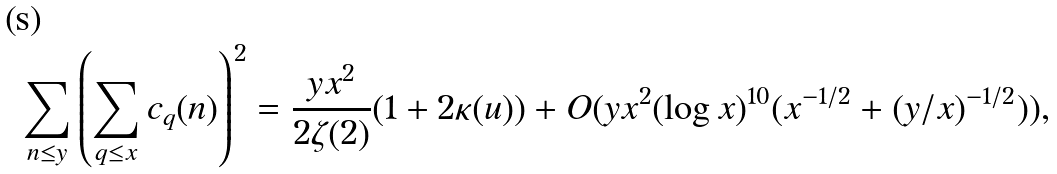Convert formula to latex. <formula><loc_0><loc_0><loc_500><loc_500>\sum _ { n \leq y } \left ( \sum _ { q \leq x } c _ { q } ( n ) \right ) ^ { 2 } = \frac { y x ^ { 2 } } { 2 \zeta ( 2 ) } ( 1 + 2 \kappa ( u ) ) + O ( y x ^ { 2 } ( \log x ) ^ { 1 0 } ( x ^ { - 1 / 2 } + ( y / x ) ^ { - 1 / 2 } ) ) ,</formula> 